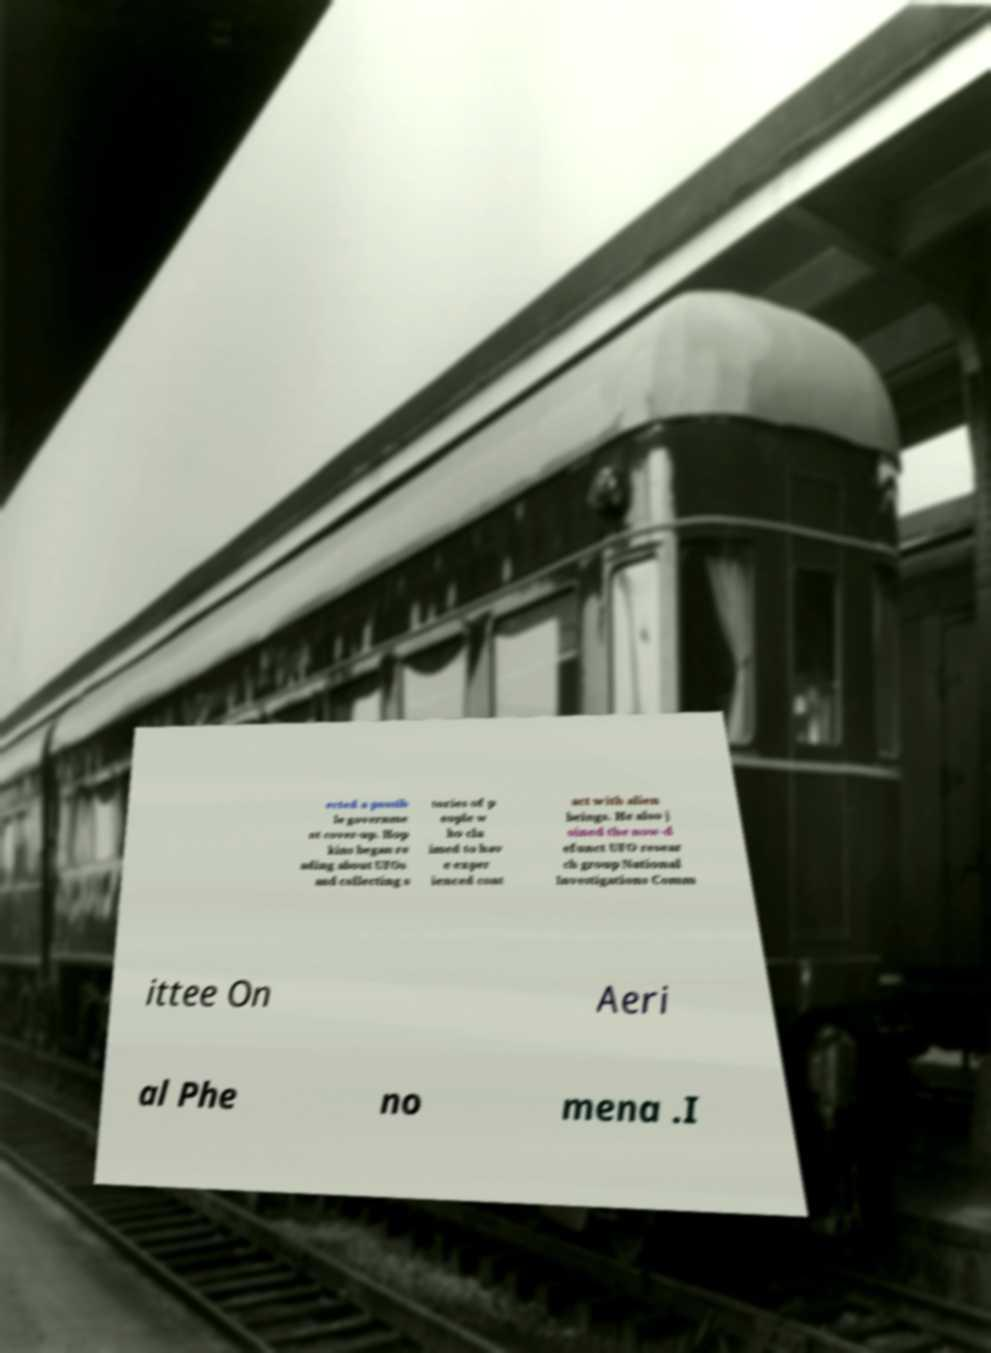Can you accurately transcribe the text from the provided image for me? ected a possib le governme nt cover-up. Hop kins began re ading about UFOs and collecting s tories of p eople w ho cla imed to hav e exper ienced cont act with alien beings. He also j oined the now-d efunct UFO resear ch group National Investigations Comm ittee On Aeri al Phe no mena .I 